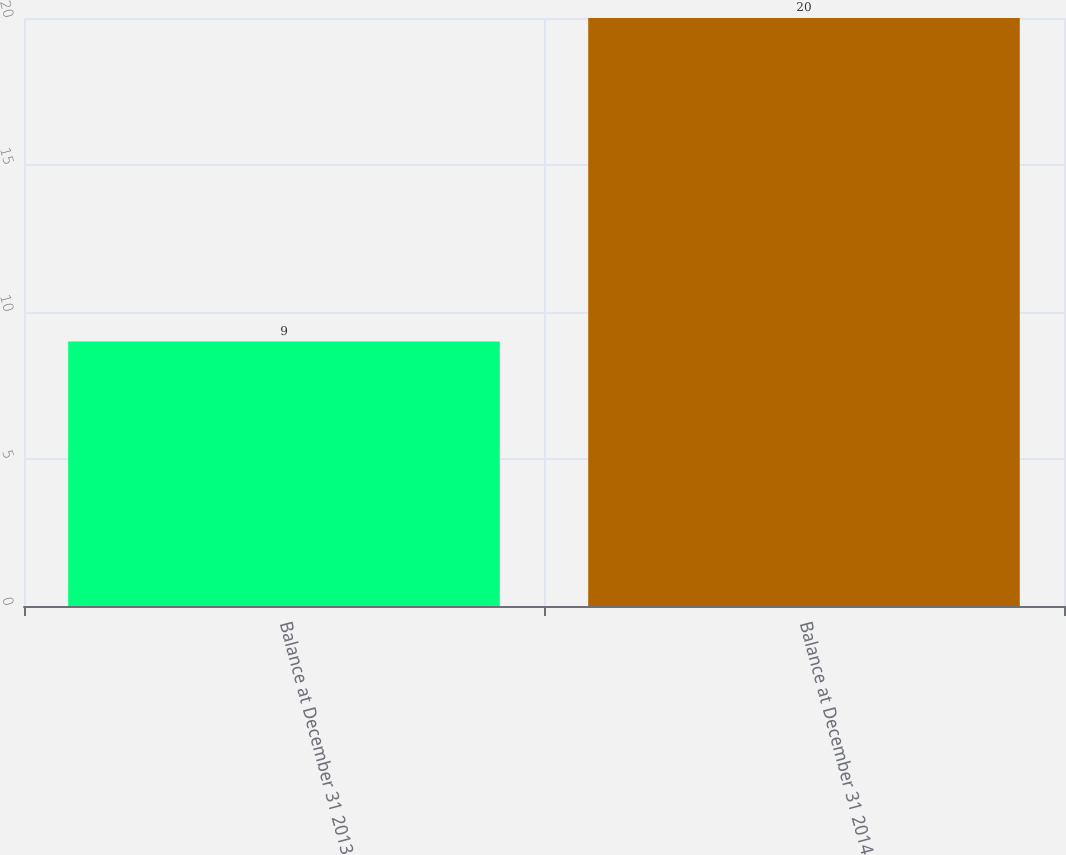<chart> <loc_0><loc_0><loc_500><loc_500><bar_chart><fcel>Balance at December 31 2013<fcel>Balance at December 31 2014<nl><fcel>9<fcel>20<nl></chart> 